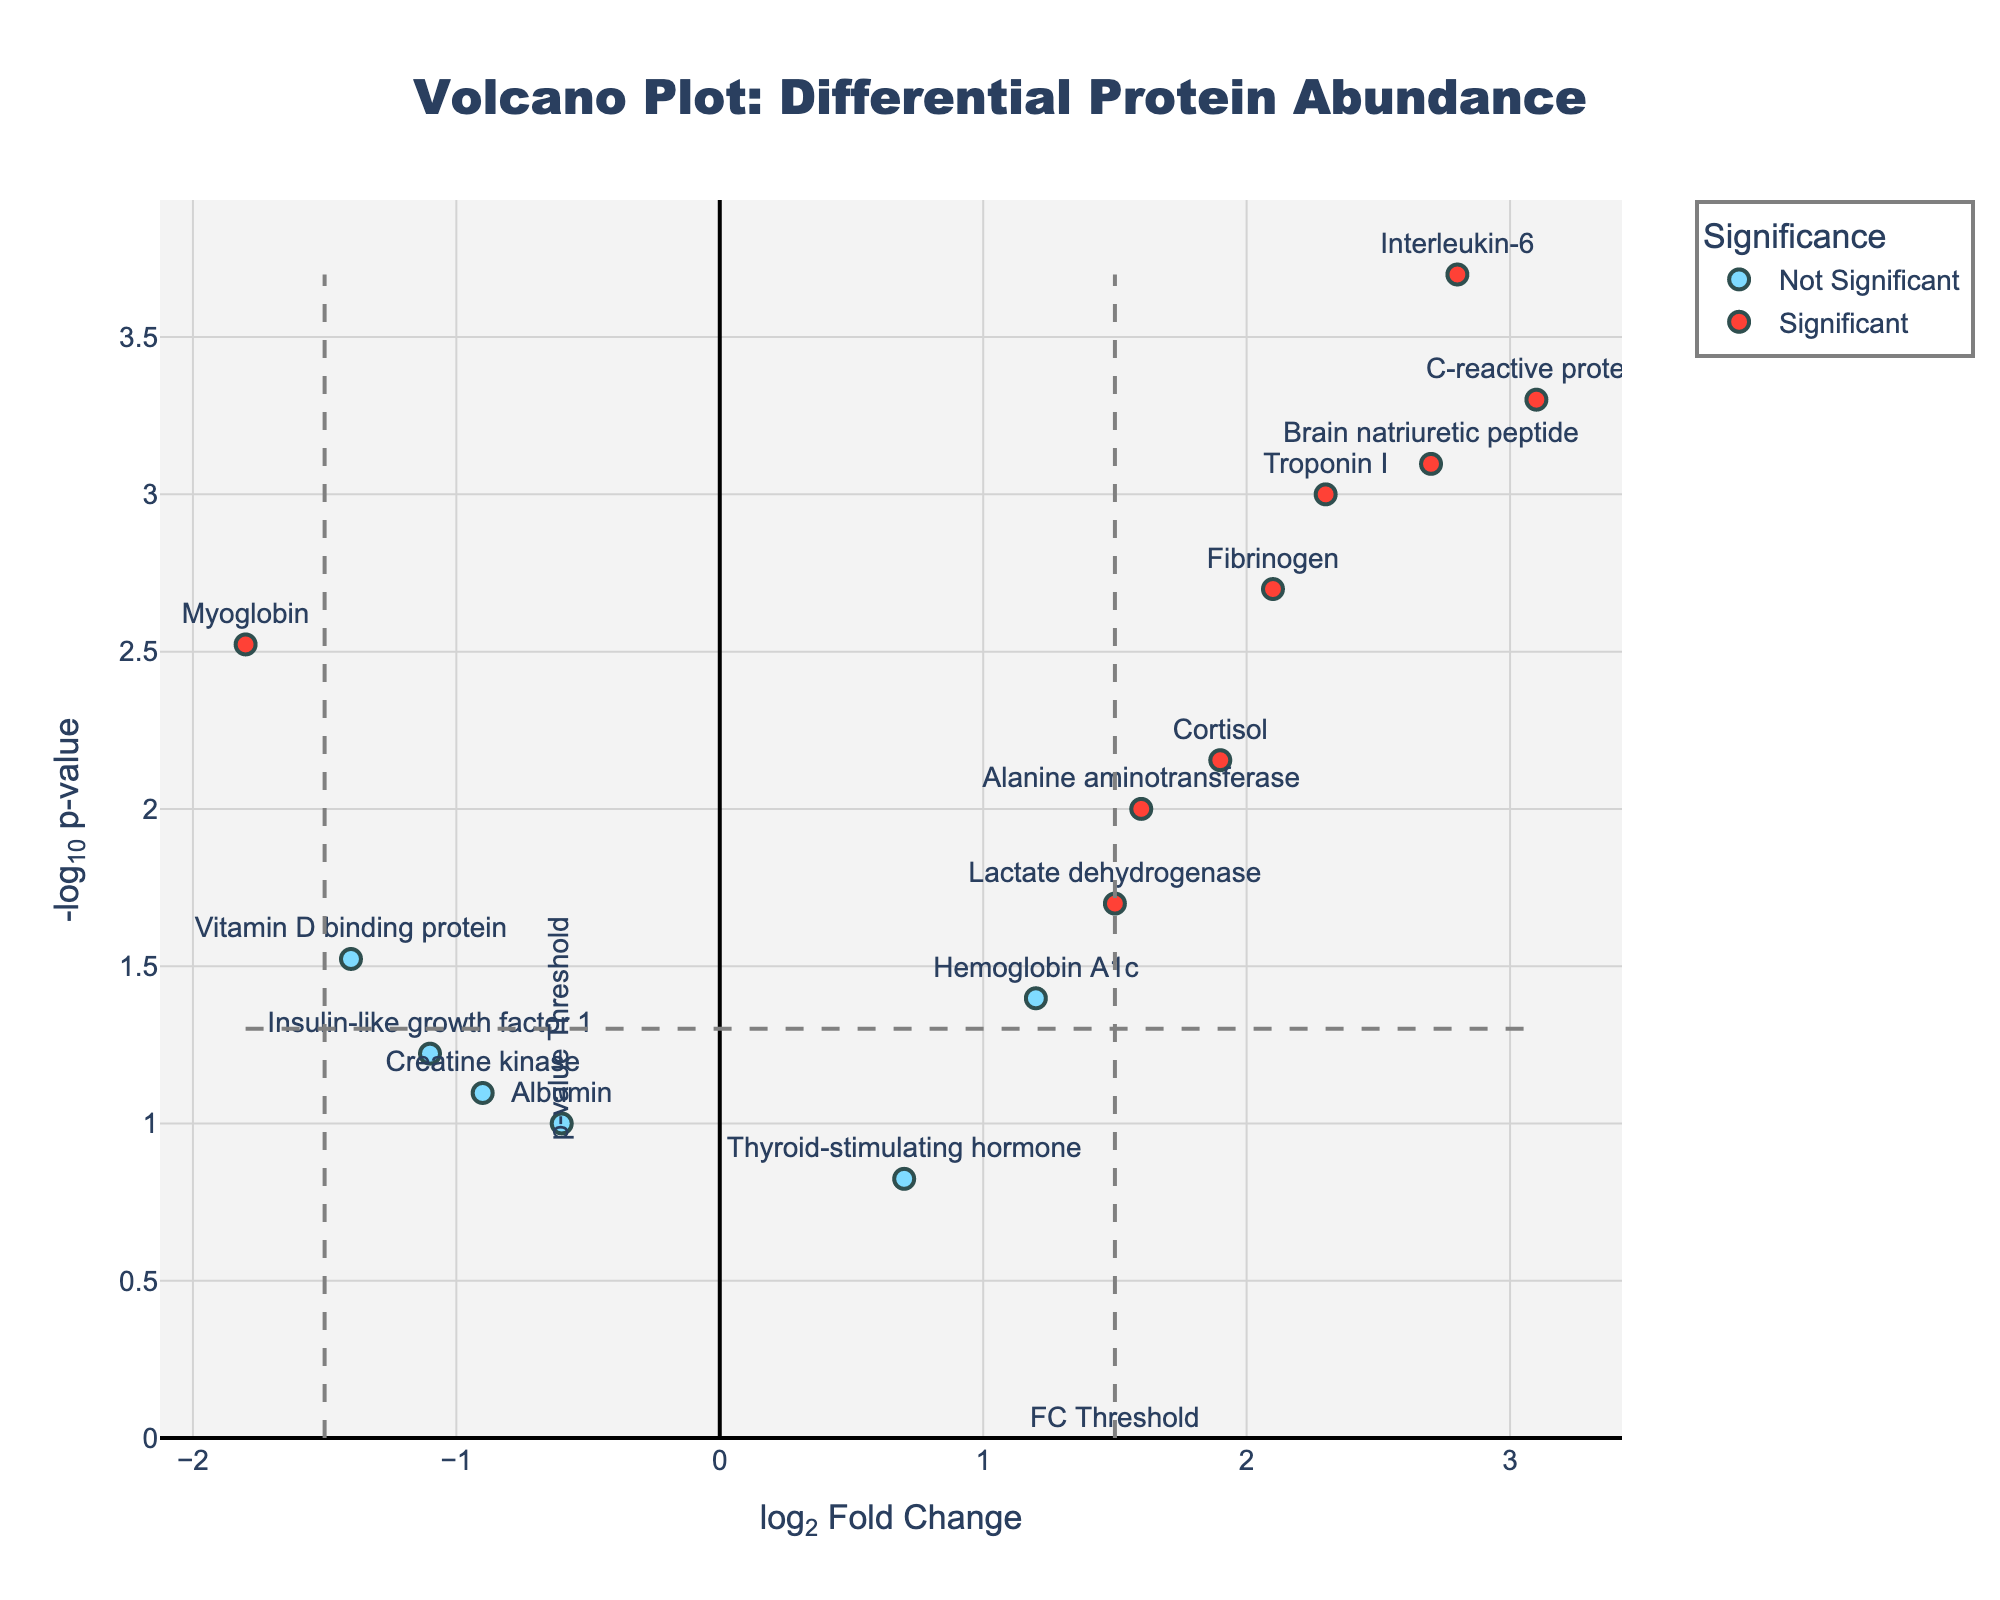What's the title of the plot? The title is located at the top and usually describes the content of the plot. In this case, it states "Volcano Plot: Differential Protein Abundance".
Answer: Volcano Plot: Differential Protein Abundance What are the labels of the x-axis and y-axis? The labels of the axes are usually found along the respective axes. Here, the x-axis is labeled "log2 Fold Change" and the y-axis is labeled "-log10 p-value".
Answer: log2 Fold Change, -log10 p-value How many data points are classified as significant? Significant data points are typically indicated by a different color. In this plot, these are the points marked by the specific threshold lines for fold change and p-value, colored distinctively (red). By counting them, we find there are 8 significant data points.
Answer: 8 Which protein has the highest log2 Fold Change? Examine the position of the data points along the x-axis to determine the highest value. The protein "C-reactive protein" is at the highest positive x-axis value.
Answer: C-reactive protein What log2 Fold Change and -log10 p-value does the "Myoglobin" protein have? Find the "Myoglobin" label and locate its corresponding x and y values. "Myoglobin" has a log2 Fold Change of -1.8 and a -log10 p-value of 2.52 (-log10(0.003)).
Answer: -1.8, 2.52 Which proteins are above the p-value threshold but below the fold change threshold? First, identify the proteins that are above the horizontal threshold line (-log10(0.05) = 1.3) but within the vertical threshold lines (-1.5 and 1.5). These proteins are "Creatine kinase", "Albumin", "Hemoglobin A1c", "Insulin-like growth factor 1", and "Thyroid-stimulating hormone".
Answer: Creatine kinase, Albumin, Hemoglobin A1c, Insulin-like growth factor 1, Thyroid-stimulating hormone How many proteins have a log2 Fold Change less than -1.0 and are considered significant? Determine the points falling to the left of -1.0 on the x-axis and with y-axis values above the threshold -log10(0.05). "Myoglobin" and "Vitamin D binding protein" fit these criteria.
Answer: 2 Which proteins are closest to the fold change and p-value thresholds and are significant? Identify points near the vertical lines at ±1.5 for fold change and the horizontal line at 1.3 for the p-value, within the significant category (red). "Brain natriuretic peptide" and "Vitamin D binding protein" are closest.
Answer: Brain natriuretic peptide, Vitamin D binding protein What’s the median log2 Fold Change value for all significant proteins? First list the log2 Fold Change values for all significant proteins: 2.3, 3.1, 2.7, 1.9, 2.8, 1.6, 2.1, -1.4. After sorting, the median value is (2.3+2.1)/2 = 2.2.
Answer: 2.2 